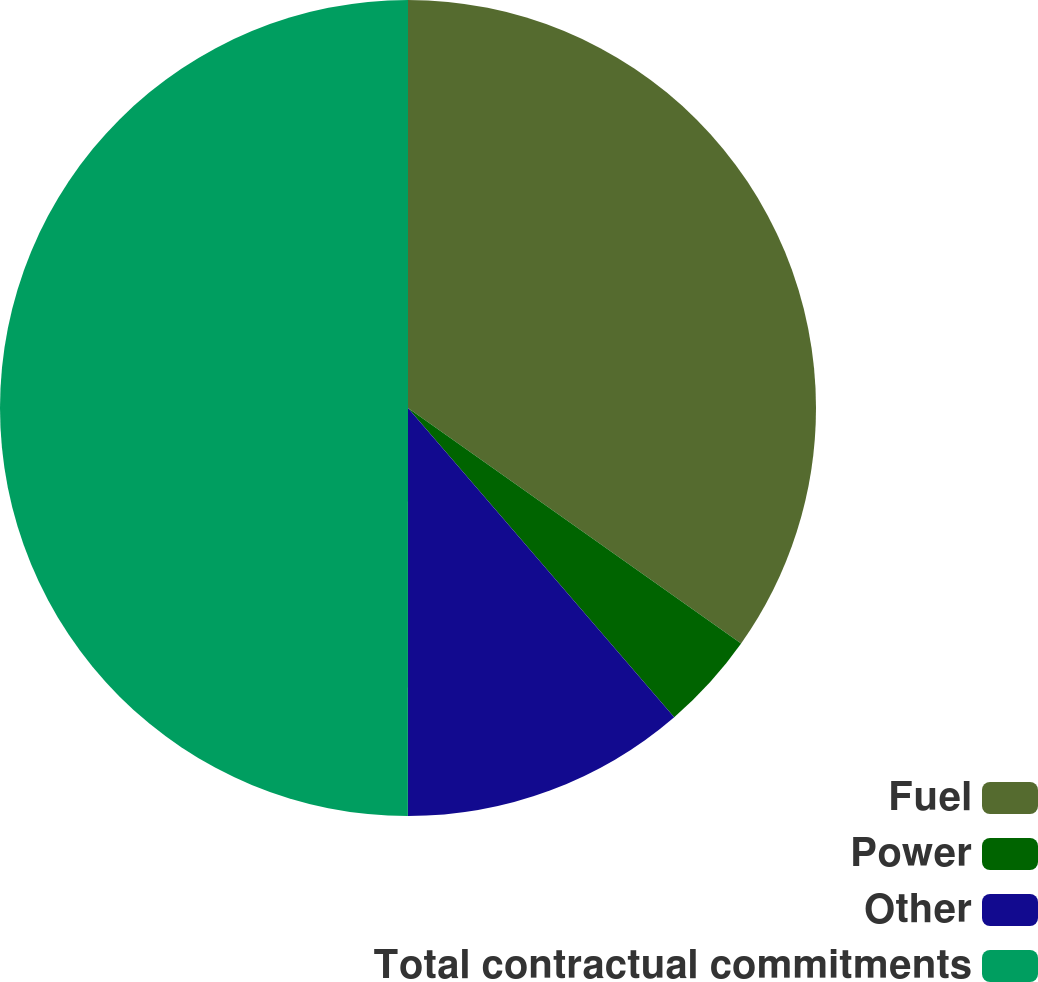Convert chart. <chart><loc_0><loc_0><loc_500><loc_500><pie_chart><fcel>Fuel<fcel>Power<fcel>Other<fcel>Total contractual commitments<nl><fcel>34.8%<fcel>3.89%<fcel>11.32%<fcel>50.0%<nl></chart> 